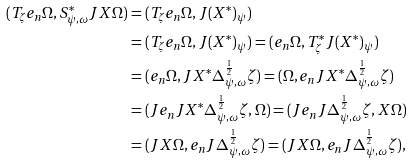Convert formula to latex. <formula><loc_0><loc_0><loc_500><loc_500>( T _ { \zeta } e _ { n } \Omega , S ^ { * } _ { \psi , \omega } J X \Omega ) & = ( T _ { \zeta } e _ { n } \Omega , J ( X ^ { * } ) _ { \psi } ) \\ & = ( T _ { \zeta } e _ { n } \Omega , J ( X ^ { * } ) _ { \psi } ) = ( e _ { n } \Omega , T ^ { * } _ { \zeta } J ( X ^ { * } ) _ { \psi } ) \\ & = ( e _ { n } \Omega , J X ^ { * } \Delta _ { \psi , \omega } ^ { \frac { 1 } { 2 } } \zeta ) = ( \Omega , e _ { n } J X ^ { * } \Delta _ { \psi , \omega } ^ { \frac { 1 } { 2 } } \zeta ) \\ & = ( J e _ { n } J X ^ { * } \Delta _ { \psi , \omega } ^ { \frac { 1 } { 2 } } \zeta , \Omega ) = ( J e _ { n } J \Delta _ { \psi , \omega } ^ { \frac { 1 } { 2 } } \zeta , X \Omega ) \\ & = ( J X \Omega , e _ { n } J \Delta _ { \psi , \omega } ^ { \frac { 1 } { 2 } } \zeta ) = ( J X \Omega , e _ { n } J \Delta _ { \psi , \omega } ^ { \frac { 1 } { 2 } } \zeta ) ,</formula> 